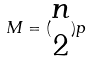<formula> <loc_0><loc_0><loc_500><loc_500>M = ( \begin{matrix} n \\ 2 \end{matrix} ) p</formula> 